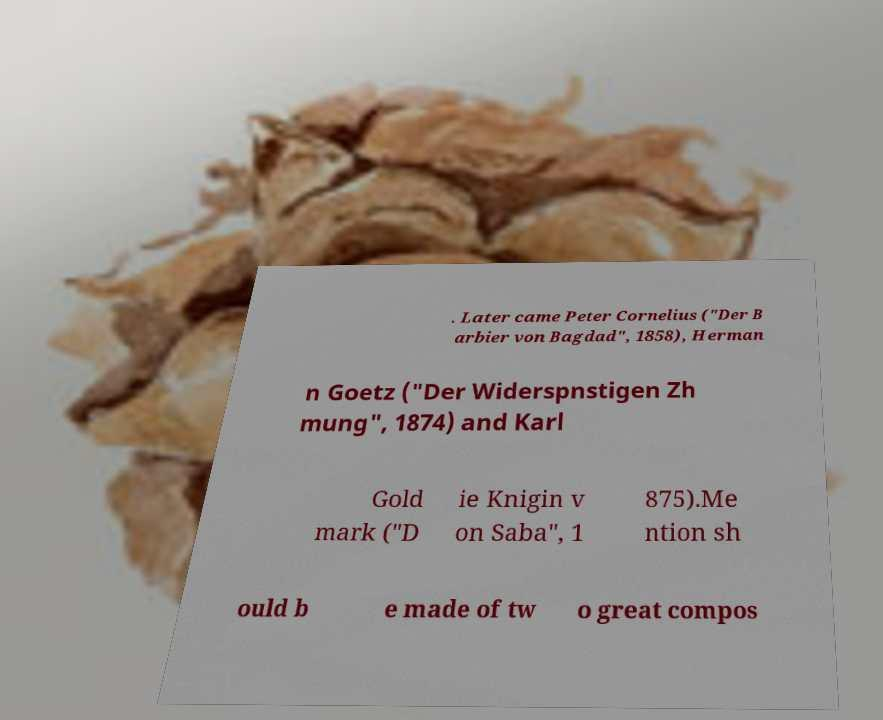What messages or text are displayed in this image? I need them in a readable, typed format. . Later came Peter Cornelius ("Der B arbier von Bagdad", 1858), Herman n Goetz ("Der Widerspnstigen Zh mung", 1874) and Karl Gold mark ("D ie Knigin v on Saba", 1 875).Me ntion sh ould b e made of tw o great compos 